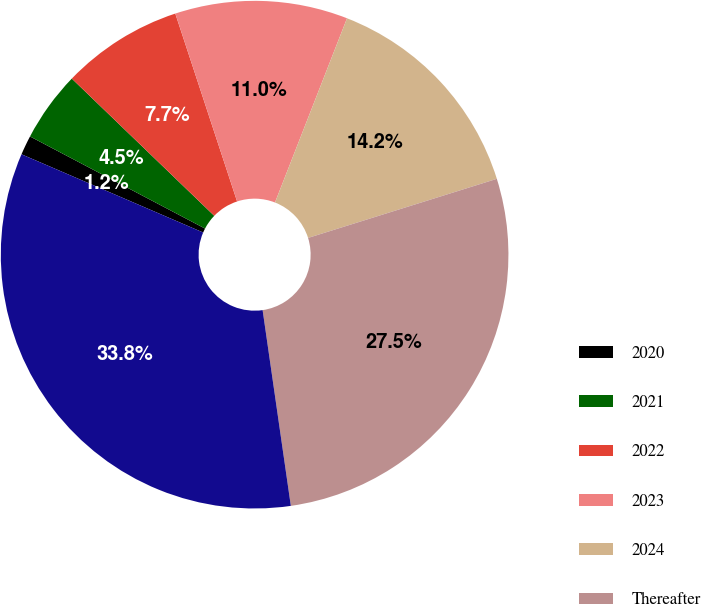<chart> <loc_0><loc_0><loc_500><loc_500><pie_chart><fcel>2020<fcel>2021<fcel>2022<fcel>2023<fcel>2024<fcel>Thereafter<fcel>Total<nl><fcel>1.24%<fcel>4.49%<fcel>7.74%<fcel>10.99%<fcel>14.24%<fcel>27.55%<fcel>33.75%<nl></chart> 